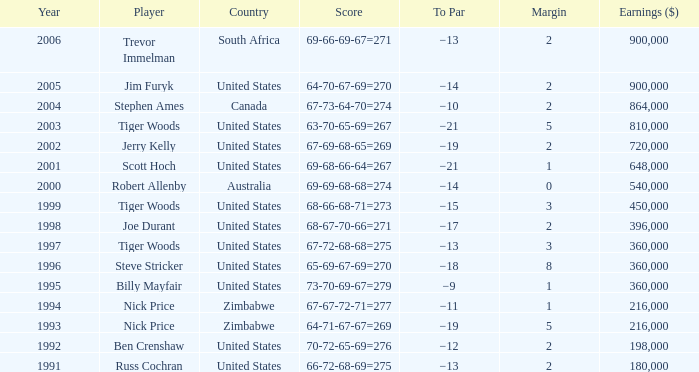In which instance does to par have earnings greater than $360,000, a year later than 1998, the united states as the country, and a score breakdown of 69-68-66-64, amounting to 267? −21. 